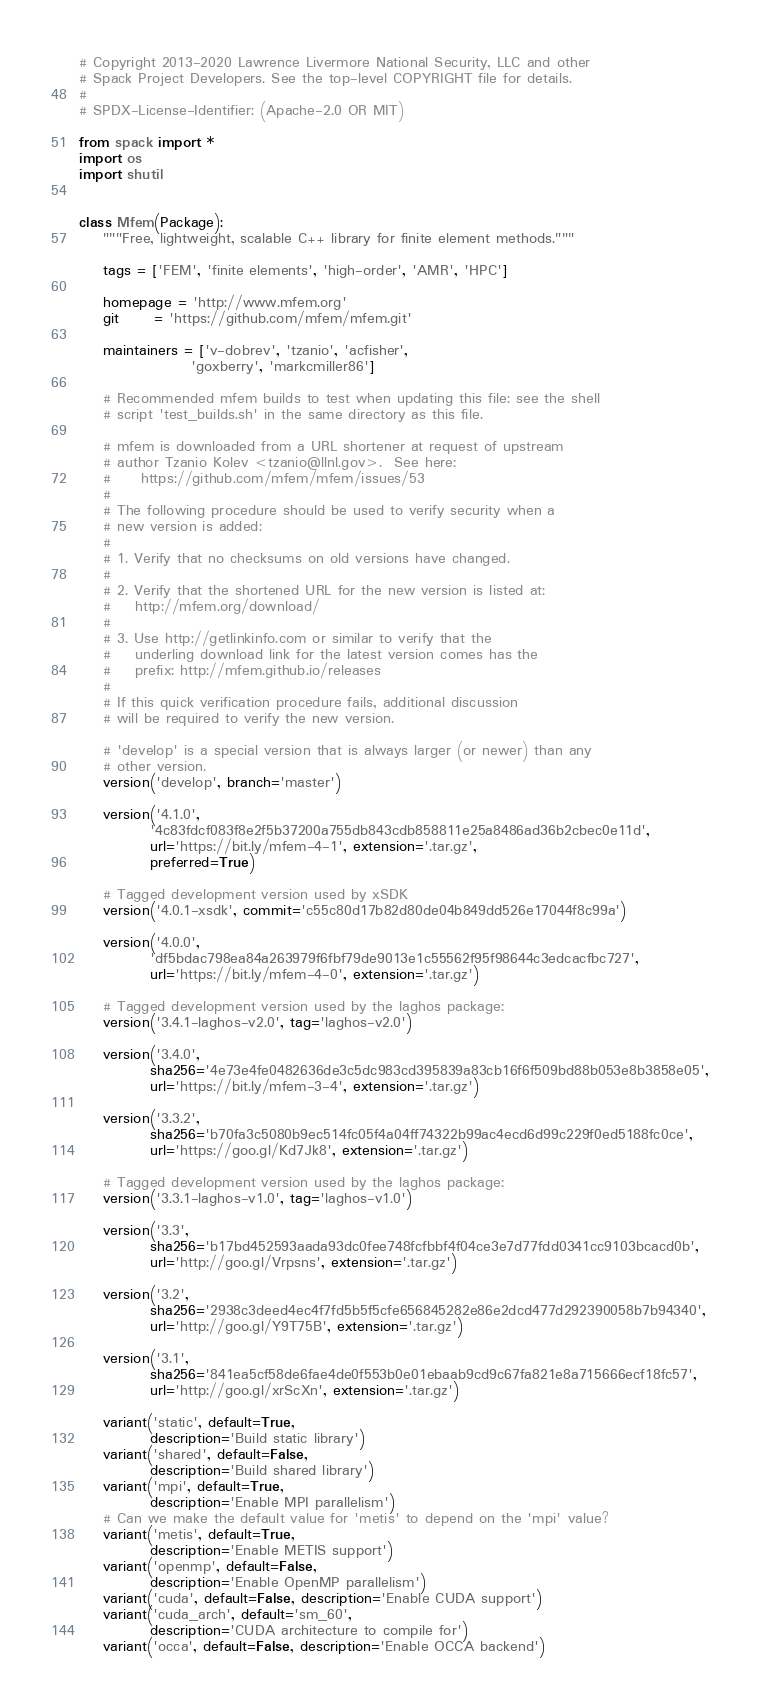<code> <loc_0><loc_0><loc_500><loc_500><_Python_># Copyright 2013-2020 Lawrence Livermore National Security, LLC and other
# Spack Project Developers. See the top-level COPYRIGHT file for details.
#
# SPDX-License-Identifier: (Apache-2.0 OR MIT)

from spack import *
import os
import shutil


class Mfem(Package):
    """Free, lightweight, scalable C++ library for finite element methods."""

    tags = ['FEM', 'finite elements', 'high-order', 'AMR', 'HPC']

    homepage = 'http://www.mfem.org'
    git      = 'https://github.com/mfem/mfem.git'

    maintainers = ['v-dobrev', 'tzanio', 'acfisher',
                   'goxberry', 'markcmiller86']

    # Recommended mfem builds to test when updating this file: see the shell
    # script 'test_builds.sh' in the same directory as this file.

    # mfem is downloaded from a URL shortener at request of upstream
    # author Tzanio Kolev <tzanio@llnl.gov>.  See here:
    #     https://github.com/mfem/mfem/issues/53
    #
    # The following procedure should be used to verify security when a
    # new version is added:
    #
    # 1. Verify that no checksums on old versions have changed.
    #
    # 2. Verify that the shortened URL for the new version is listed at:
    #    http://mfem.org/download/
    #
    # 3. Use http://getlinkinfo.com or similar to verify that the
    #    underling download link for the latest version comes has the
    #    prefix: http://mfem.github.io/releases
    #
    # If this quick verification procedure fails, additional discussion
    # will be required to verify the new version.

    # 'develop' is a special version that is always larger (or newer) than any
    # other version.
    version('develop', branch='master')

    version('4.1.0',
            '4c83fdcf083f8e2f5b37200a755db843cdb858811e25a8486ad36b2cbec0e11d',
            url='https://bit.ly/mfem-4-1', extension='.tar.gz',
            preferred=True)

    # Tagged development version used by xSDK
    version('4.0.1-xsdk', commit='c55c80d17b82d80de04b849dd526e17044f8c99a')

    version('4.0.0',
            'df5bdac798ea84a263979f6fbf79de9013e1c55562f95f98644c3edcacfbc727',
            url='https://bit.ly/mfem-4-0', extension='.tar.gz')

    # Tagged development version used by the laghos package:
    version('3.4.1-laghos-v2.0', tag='laghos-v2.0')

    version('3.4.0',
            sha256='4e73e4fe0482636de3c5dc983cd395839a83cb16f6f509bd88b053e8b3858e05',
            url='https://bit.ly/mfem-3-4', extension='.tar.gz')

    version('3.3.2',
            sha256='b70fa3c5080b9ec514fc05f4a04ff74322b99ac4ecd6d99c229f0ed5188fc0ce',
            url='https://goo.gl/Kd7Jk8', extension='.tar.gz')

    # Tagged development version used by the laghos package:
    version('3.3.1-laghos-v1.0', tag='laghos-v1.0')

    version('3.3',
            sha256='b17bd452593aada93dc0fee748fcfbbf4f04ce3e7d77fdd0341cc9103bcacd0b',
            url='http://goo.gl/Vrpsns', extension='.tar.gz')

    version('3.2',
            sha256='2938c3deed4ec4f7fd5b5f5cfe656845282e86e2dcd477d292390058b7b94340',
            url='http://goo.gl/Y9T75B', extension='.tar.gz')

    version('3.1',
            sha256='841ea5cf58de6fae4de0f553b0e01ebaab9cd9c67fa821e8a715666ecf18fc57',
            url='http://goo.gl/xrScXn', extension='.tar.gz')

    variant('static', default=True,
            description='Build static library')
    variant('shared', default=False,
            description='Build shared library')
    variant('mpi', default=True,
            description='Enable MPI parallelism')
    # Can we make the default value for 'metis' to depend on the 'mpi' value?
    variant('metis', default=True,
            description='Enable METIS support')
    variant('openmp', default=False,
            description='Enable OpenMP parallelism')
    variant('cuda', default=False, description='Enable CUDA support')
    variant('cuda_arch', default='sm_60',
            description='CUDA architecture to compile for')
    variant('occa', default=False, description='Enable OCCA backend')</code> 